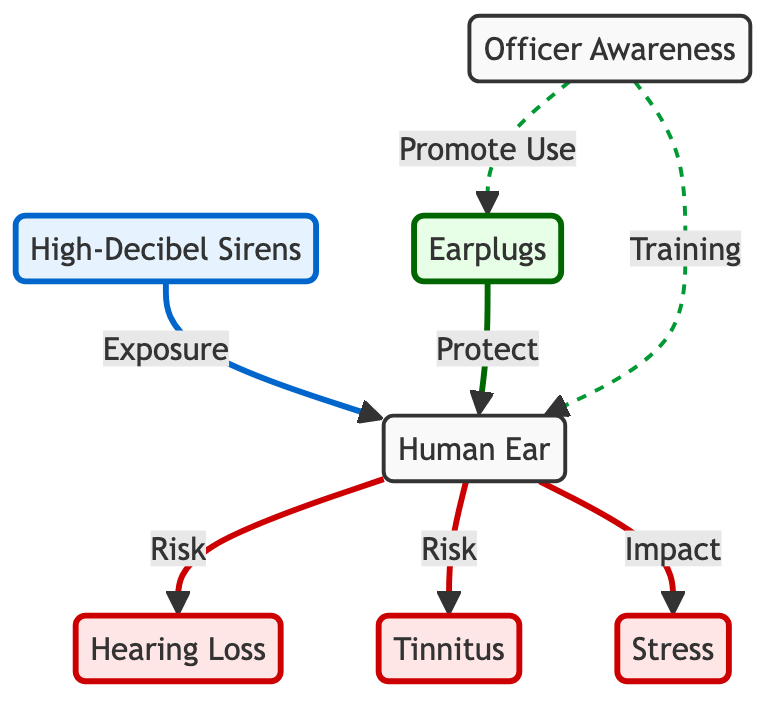What are the effects of high-decibel sirens on the human ear? The diagram shows that high-decibel sirens can lead to three effects on the human ear: hearing loss, tinnitus, and stress. These are directly connected as risks and impacts from the exposure to the sirens.
Answer: Hearing Loss, Tinnitus, Stress What protective gear is suggested in the diagram? The diagram clearly labels earplugs as the protective gear recommended to help mitigate the risks to the ear from high-decibel sirens.
Answer: Earplugs How many total effects are illustrated as resulting from exposure to high-decibel sirens? The diagram lists three distinct effects resulting from exposure to high-decibel sirens: hearing loss, tinnitus, and stress. Counting these gives the total number of effects.
Answer: 3 What relationship exists between officer awareness and the use of earplugs? The diagram indicates a direct relationship where officer awareness leads to the promotion of earplug use as a protective measure against ear damage from sirens.
Answer: Promote Use Which node represents the source of high-decibel exposure? The high-decibel sirens node is identified as the source of exposure leading to effects on the ear, as indicated by the flow from the sirens to the ear node.
Answer: High-Decibel Sirens Which effects are classified as risks associated with the human ear? The risks associated with the human ear, as illustrated in the diagram, include hearing loss, tinnitus, and stress as effects of exposure.
Answer: Hearing Loss, Tinnitus, Stress What does the arrow from 'Officer Awareness' to 'Earplugs' signify? The arrow indicates that the awareness of officers leads to actively promoting the use of earplugs for protection against hearing damage, showing a proactive safety approach.
Answer: Promote Use How do earplugs contribute to the human ear in the context of the diagram? Earplugs are depicted in the diagram as protective gear specifically designed to protect the human ear from the negative effects of high-decibel sirens.
Answer: Protect 